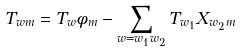Convert formula to latex. <formula><loc_0><loc_0><loc_500><loc_500>T _ { w m } = T _ { w } \phi _ { m } - \sum _ { w = w _ { 1 } w _ { 2 } } T _ { w _ { 1 } } X _ { w _ { 2 } m }</formula> 